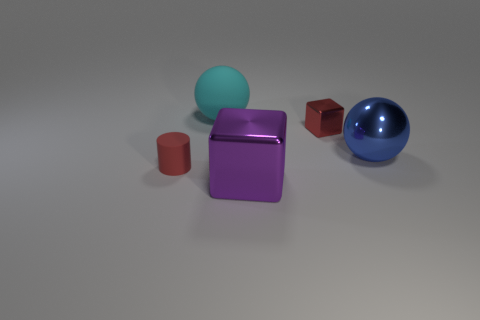What is the material of the other tiny object that is the same color as the small rubber object?
Give a very brief answer. Metal. There is a metallic block in front of the big blue metallic object; does it have the same size as the metallic block that is behind the large shiny cube?
Ensure brevity in your answer.  No. Is the number of tiny blocks less than the number of tiny blue metallic spheres?
Make the answer very short. No. How many matte things are tiny cubes or big brown balls?
Offer a terse response. 0. Is there a big block that is in front of the shiny thing that is in front of the large shiny sphere?
Provide a short and direct response. No. Is the material of the object behind the small metal cube the same as the purple object?
Give a very brief answer. No. What number of other objects are there of the same color as the large metal cube?
Give a very brief answer. 0. Do the cylinder and the small metallic cube have the same color?
Keep it short and to the point. Yes. What is the size of the block that is on the left side of the red cube that is right of the tiny red cylinder?
Provide a short and direct response. Large. Does the small thing that is on the right side of the large cyan thing have the same material as the big thing on the right side of the big purple shiny thing?
Provide a short and direct response. Yes. 